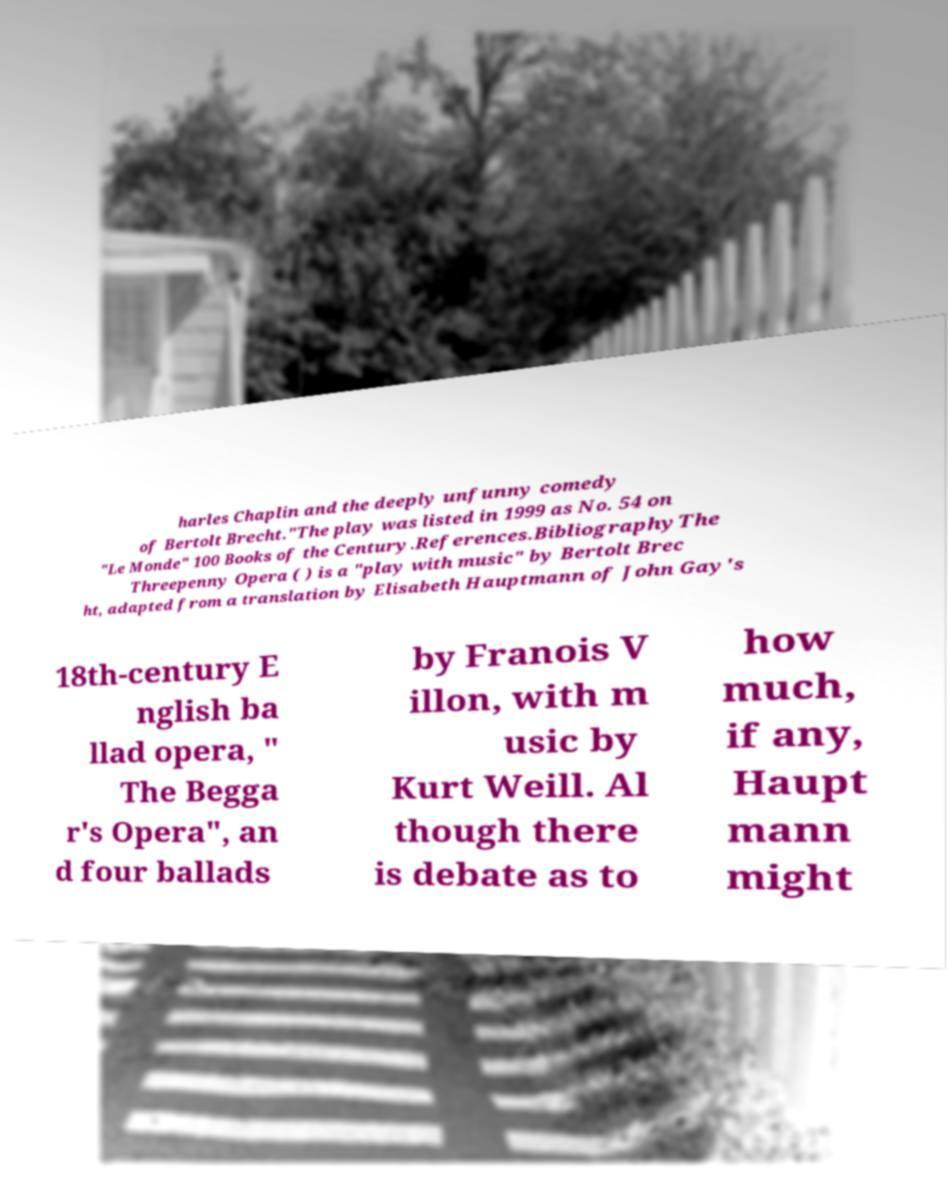Can you accurately transcribe the text from the provided image for me? harles Chaplin and the deeply unfunny comedy of Bertolt Brecht."The play was listed in 1999 as No. 54 on "Le Monde" 100 Books of the Century.References.BibliographyThe Threepenny Opera ( ) is a "play with music" by Bertolt Brec ht, adapted from a translation by Elisabeth Hauptmann of John Gay's 18th-century E nglish ba llad opera, " The Begga r's Opera", an d four ballads by Franois V illon, with m usic by Kurt Weill. Al though there is debate as to how much, if any, Haupt mann might 